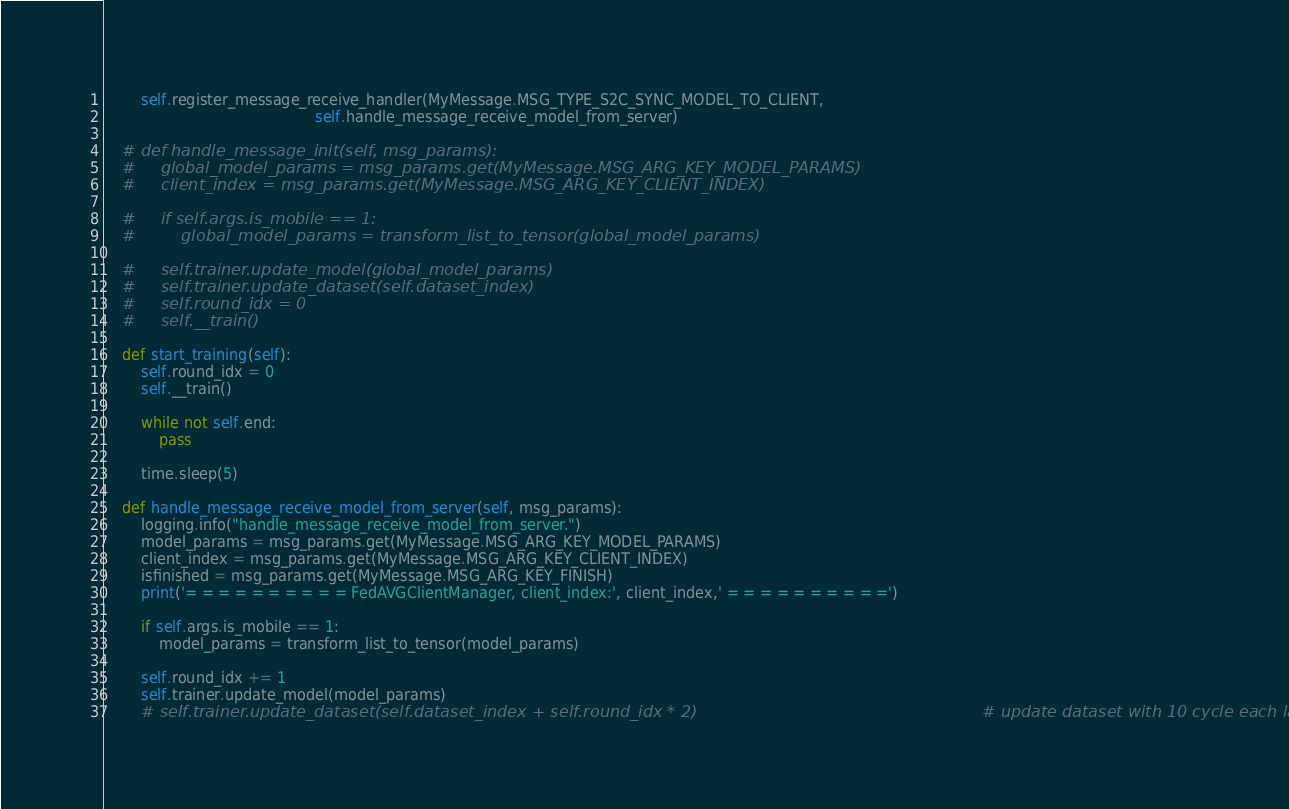<code> <loc_0><loc_0><loc_500><loc_500><_Python_>        self.register_message_receive_handler(MyMessage.MSG_TYPE_S2C_SYNC_MODEL_TO_CLIENT,
                                              self.handle_message_receive_model_from_server)

    # def handle_message_init(self, msg_params):
    #     global_model_params = msg_params.get(MyMessage.MSG_ARG_KEY_MODEL_PARAMS)
    #     client_index = msg_params.get(MyMessage.MSG_ARG_KEY_CLIENT_INDEX)

    #     if self.args.is_mobile == 1:
    #         global_model_params = transform_list_to_tensor(global_model_params)

    #     self.trainer.update_model(global_model_params)
    #     self.trainer.update_dataset(self.dataset_index)
    #     self.round_idx = 0
    #     self.__train()

    def start_training(self):
        self.round_idx = 0
        self.__train()

        while not self.end:
            pass

        time.sleep(5)

    def handle_message_receive_model_from_server(self, msg_params):
        logging.info("handle_message_receive_model_from_server.")
        model_params = msg_params.get(MyMessage.MSG_ARG_KEY_MODEL_PARAMS)
        client_index = msg_params.get(MyMessage.MSG_ARG_KEY_CLIENT_INDEX)
        isfinished = msg_params.get(MyMessage.MSG_ARG_KEY_FINISH)
        print('= = = = = = = = = = FedAVGClientManager, client_index:', client_index,' = = = = = = = = = =')

        if self.args.is_mobile == 1:
            model_params = transform_list_to_tensor(model_params)

        self.round_idx += 1
        self.trainer.update_model(model_params)
        # self.trainer.update_dataset(self.dataset_index + self.round_idx * 2)                                                        # update dataset with 10 cycle each label</code> 